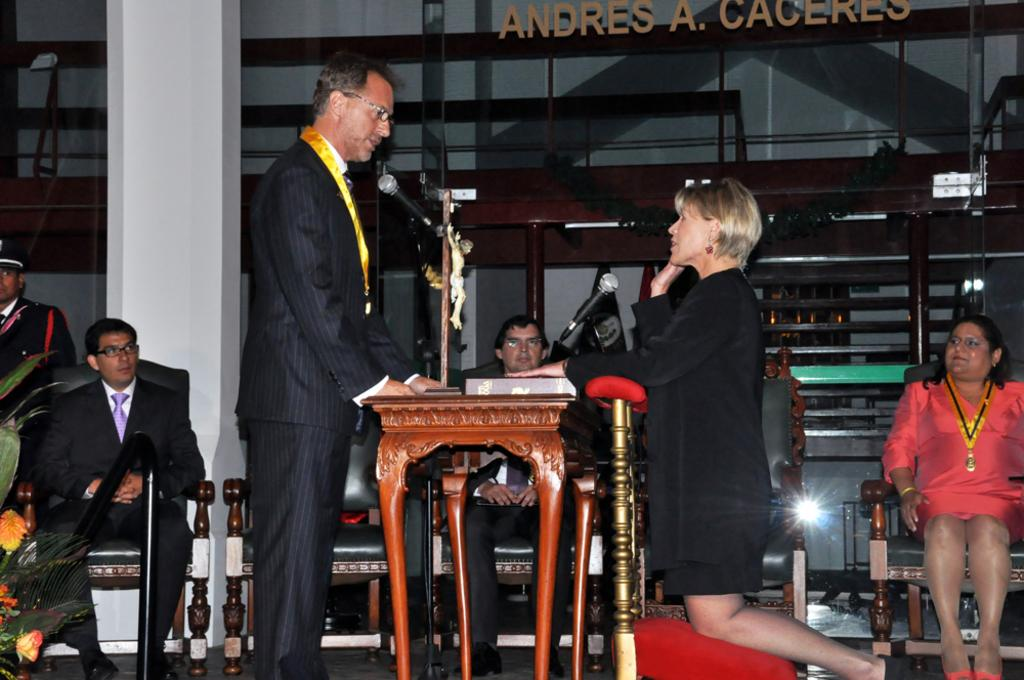What are the people in the image doing? The persons sitting on chairs in the image suggest they might be engaged in a discussion or meeting. What is on the table in the image? The presence of a microphone (mike) on the table in the image indicates that it might be used for amplifying sound during a presentation or speech. What can be seen in the background of the image? There is a pillar in the background of the image, which could provide structural support or serve as a decorative element. What type of vegetation is present in the image? There is a plant in the image, which adds a natural element to the setting. How many knots are tied in the arm of the person sitting on the chair? There are no knots or references to knots in the image; the focus is on the persons sitting on chairs, the table, the microphone, the pillar, and the plant. What type of donkey can be seen in the image? There is no donkey present in the image; the focus is on the persons sitting on chairs, the table, the microphone, the pillar, and the plant. 